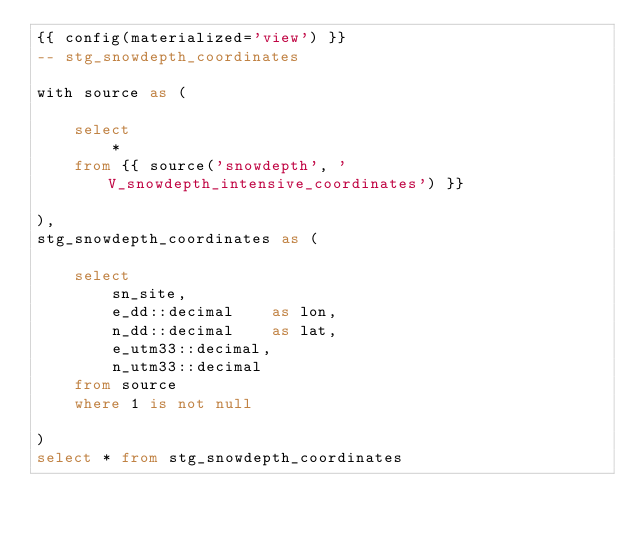Convert code to text. <code><loc_0><loc_0><loc_500><loc_500><_SQL_>{{ config(materialized='view') }}
-- stg_snowdepth_coordinates

with source as (

    select
        *
    from {{ source('snowdepth', 'V_snowdepth_intensive_coordinates') }}

),
stg_snowdepth_coordinates as (

    select
        sn_site,
        e_dd::decimal    as lon,
        n_dd::decimal    as lat,
        e_utm33::decimal,
        n_utm33::decimal
    from source
    where 1 is not null

)
select * from stg_snowdepth_coordinates</code> 